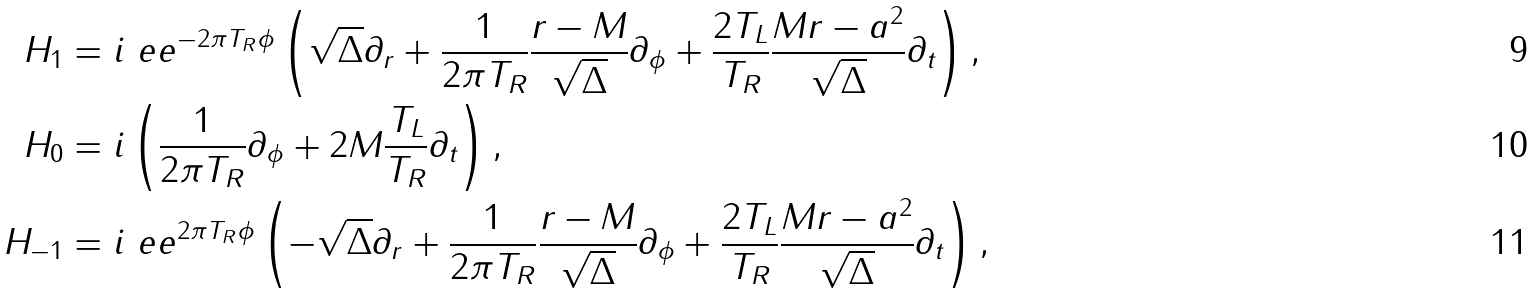Convert formula to latex. <formula><loc_0><loc_0><loc_500><loc_500>H _ { 1 } & = i \ e e ^ { - 2 \pi T _ { R } \phi } \left ( \sqrt { \Delta } \partial _ { r } + \frac { 1 } { 2 \pi T _ { R } } \frac { r - M } { \sqrt { \Delta } } \partial _ { \phi } + \frac { 2 T _ { L } } { T _ { R } } \frac { M r - a ^ { 2 } } { \sqrt { \Delta } } \partial _ { t } \right ) , \\ H _ { 0 } & = i \left ( \frac { 1 } { 2 \pi T _ { R } } \partial _ { \phi } + 2 M \frac { T _ { L } } { T _ { R } } \partial _ { t } \right ) , \\ H _ { - 1 } & = i \ e e ^ { 2 \pi T _ { R } \phi } \left ( - \sqrt { \Delta } \partial _ { r } + \frac { 1 } { 2 \pi T _ { R } } \frac { r - M } { \sqrt { \Delta } } \partial _ { \phi } + \frac { 2 T _ { L } } { T _ { R } } \frac { M r - a ^ { 2 } } { \sqrt { \Delta } } \partial _ { t } \right ) ,</formula> 